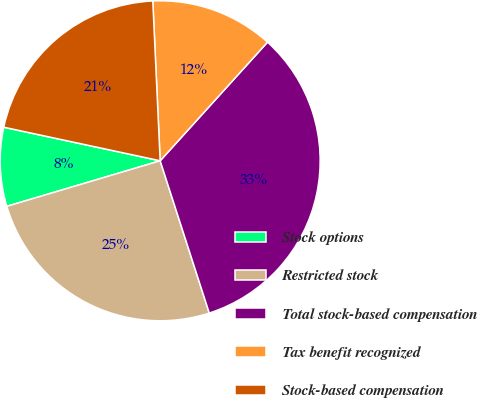<chart> <loc_0><loc_0><loc_500><loc_500><pie_chart><fcel>Stock options<fcel>Restricted stock<fcel>Total stock-based compensation<fcel>Tax benefit recognized<fcel>Stock-based compensation<nl><fcel>7.96%<fcel>25.37%<fcel>33.33%<fcel>12.44%<fcel>20.9%<nl></chart> 